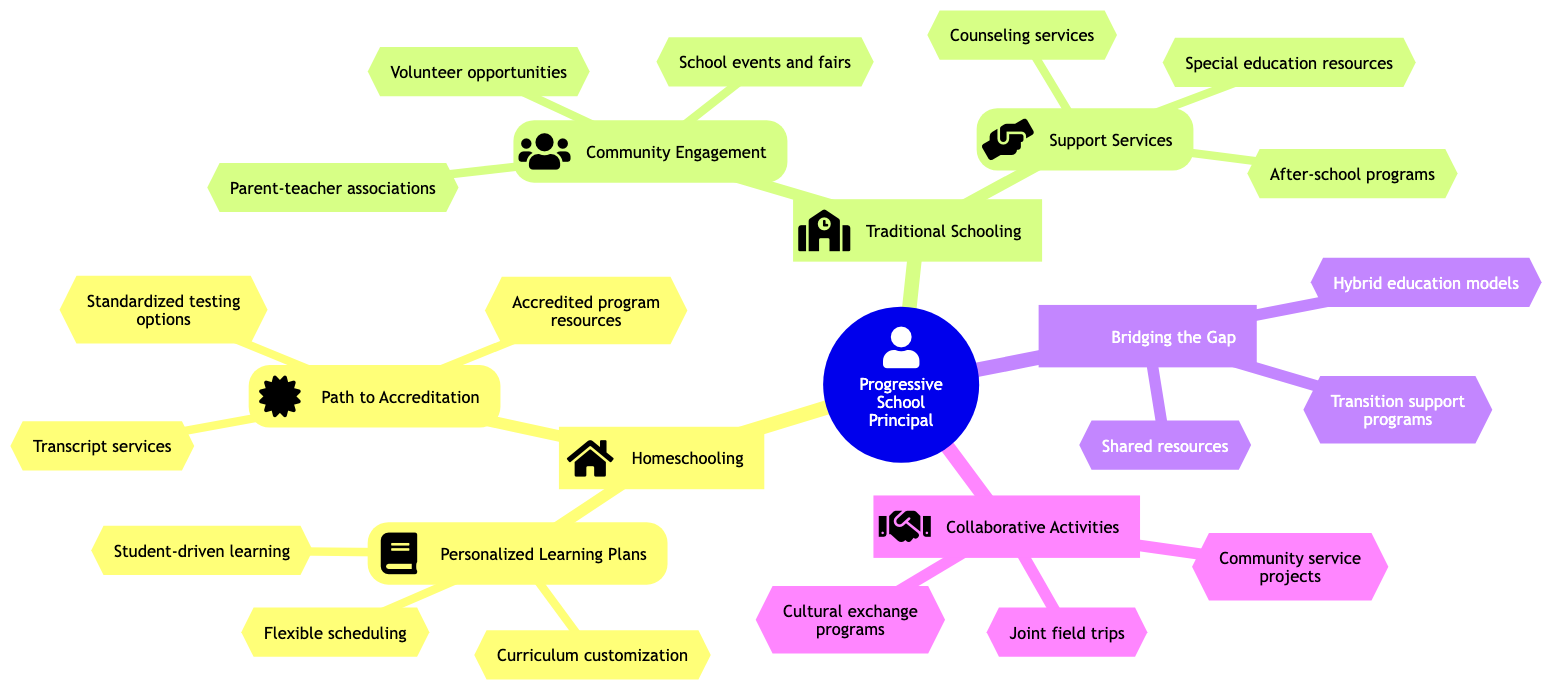What are the two main branches in the family tree? The diagram has two main branches: "Homeschooling" and "Traditional Schooling."
Answer: Homeschooling, Traditional Schooling How many sub-branches are there under "Homeschooling"? Under "Homeschooling," there are two sub-branches: "Personalized Learning Plans" and "Path to Accreditation."
Answer: 2 What shared resource is found under "Bridging the Gap"? The diagram lists "Shared resources" as one of the attributes under "Bridging the Gap."
Answer: Shared resources Identify one community engagement activity listed in the "Community Engagement" branch. The "Community Engagement" branch contains activities such as "Parent-teacher associations," "School events and fairs," and "Volunteer opportunities." Selecting one, "Parent-teacher associations" is an example.
Answer: Parent-teacher associations What connects "Homeschooling" to "Traditional Schooling"? The diagram depicts "Bridging the Gap" and "Collaborative Activities" as connecting elements between "Homeschooling" and "Traditional Schooling."
Answer: Bridging the Gap, Collaborative Activities Which branch focuses on support services for students? The "Support Services" sub-branch under "Traditional Schooling" focuses on services such as counseling and special education.
Answer: Support Services What type of learning is emphasized in "Personalized Learning Plans"? The emphasis in "Personalized Learning Plans" is on student-driven learning, along with curriculum customization and flexible scheduling.
Answer: Student-driven learning How many attributes are listed under "Community Engagement"? The "Community Engagement" branch lists three attributes: "Parent-teacher associations," "School events and fairs," and "Volunteer opportunities."
Answer: 3 What is one of the activities listed under "Collaborative Activities"? One activity under "Collaborative Activities" is "Joint field trips," which is listed among other activities like cultural exchange and community service.
Answer: Joint field trips 